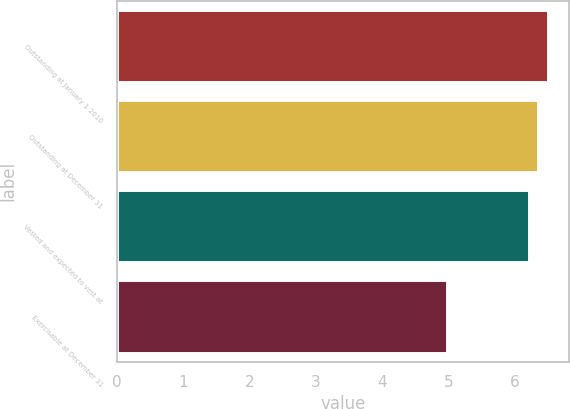Convert chart. <chart><loc_0><loc_0><loc_500><loc_500><bar_chart><fcel>Outstanding at January 1 2010<fcel>Outstanding at December 31<fcel>Vested and expected to vest at<fcel>Exercisable at December 31<nl><fcel>6.49<fcel>6.35<fcel>6.21<fcel>4.97<nl></chart> 